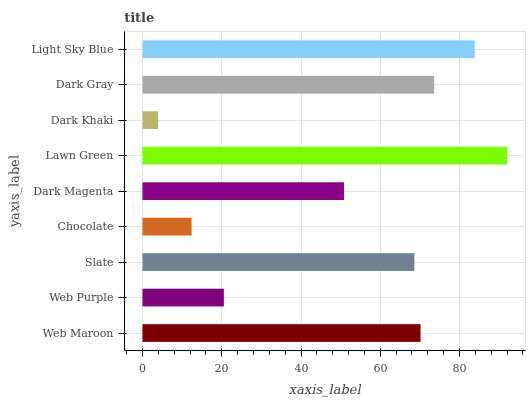Is Dark Khaki the minimum?
Answer yes or no. Yes. Is Lawn Green the maximum?
Answer yes or no. Yes. Is Web Purple the minimum?
Answer yes or no. No. Is Web Purple the maximum?
Answer yes or no. No. Is Web Maroon greater than Web Purple?
Answer yes or no. Yes. Is Web Purple less than Web Maroon?
Answer yes or no. Yes. Is Web Purple greater than Web Maroon?
Answer yes or no. No. Is Web Maroon less than Web Purple?
Answer yes or no. No. Is Slate the high median?
Answer yes or no. Yes. Is Slate the low median?
Answer yes or no. Yes. Is Dark Magenta the high median?
Answer yes or no. No. Is Dark Khaki the low median?
Answer yes or no. No. 